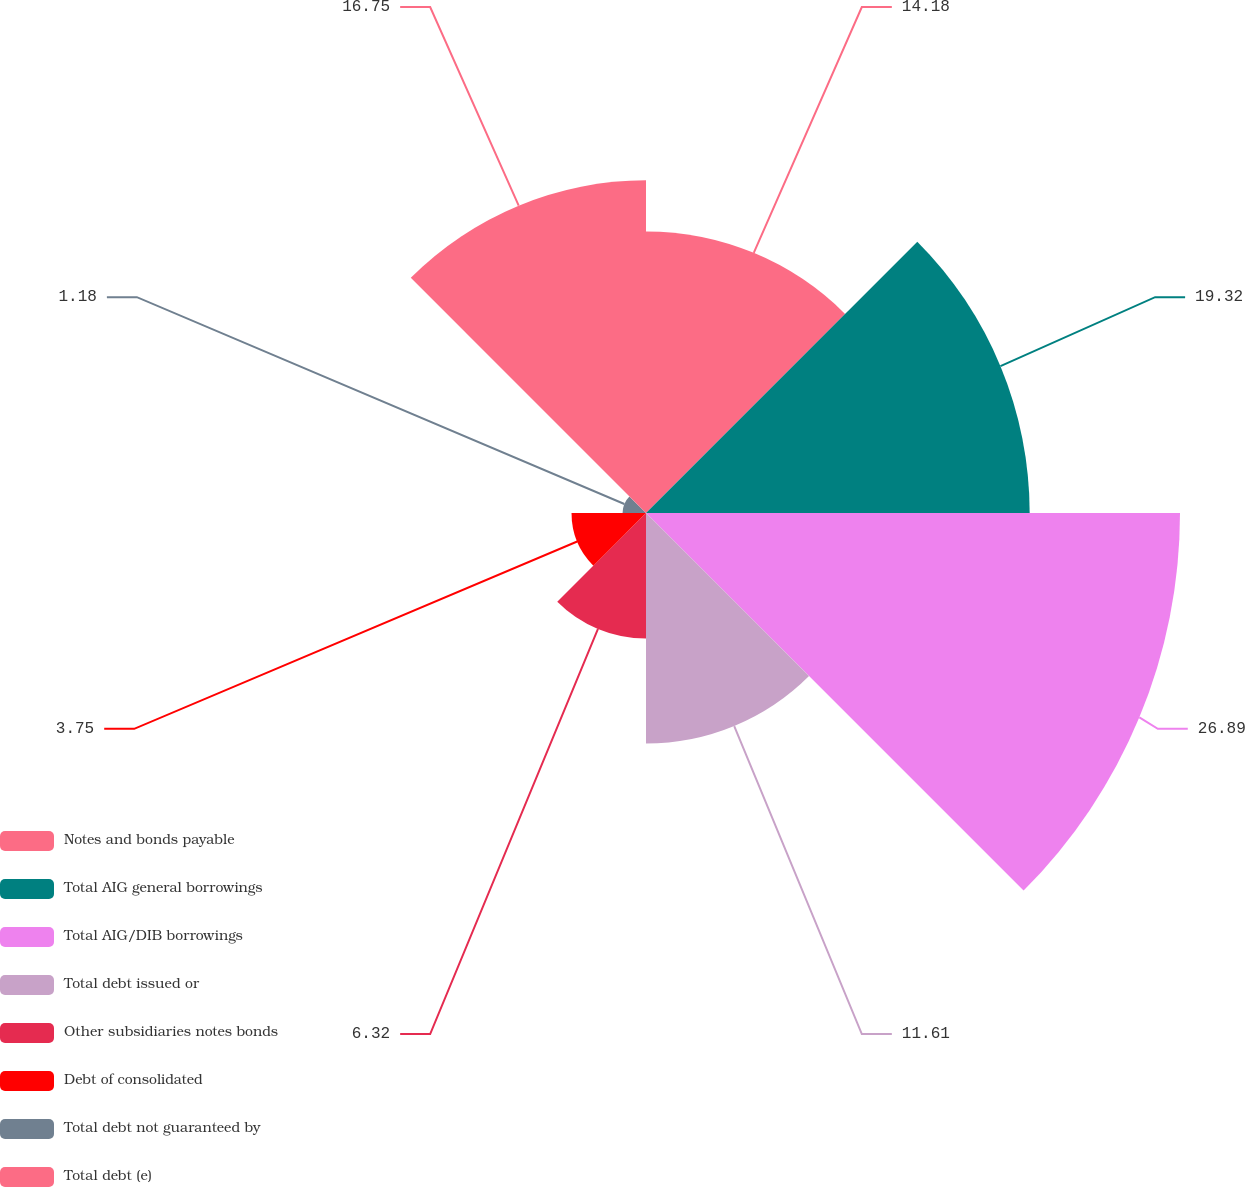Convert chart. <chart><loc_0><loc_0><loc_500><loc_500><pie_chart><fcel>Notes and bonds payable<fcel>Total AIG general borrowings<fcel>Total AIG/DIB borrowings<fcel>Total debt issued or<fcel>Other subsidiaries notes bonds<fcel>Debt of consolidated<fcel>Total debt not guaranteed by<fcel>Total debt (e)<nl><fcel>14.18%<fcel>19.32%<fcel>26.89%<fcel>11.61%<fcel>6.32%<fcel>3.75%<fcel>1.18%<fcel>16.75%<nl></chart> 